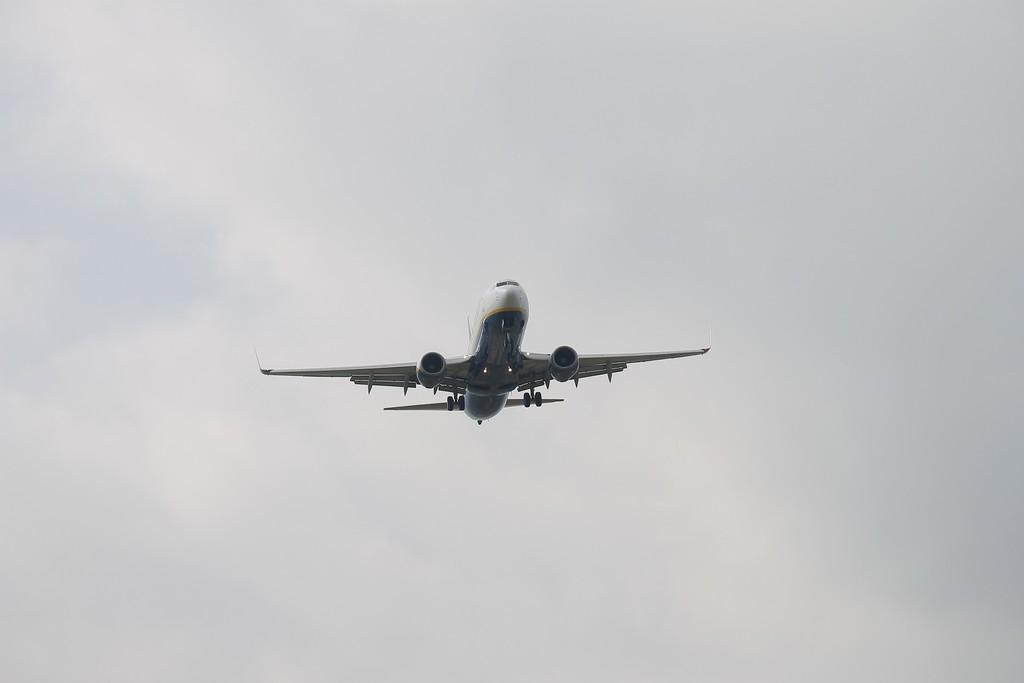What is the main subject of the image? The main subject of the image is an airplane. Can you describe the location of the airplane in the image? The airplane is in the air in the image. What can be seen in the background of the image? There are clouds and the sky visible in the background of the image. What type of sheet is being used to cover the farm in the image? There is no farm or sheet present in the image; it only features an airplane in the sky. 